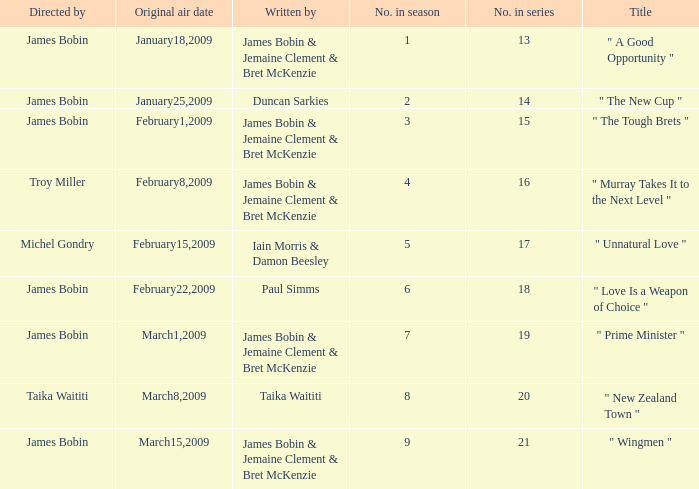 what's the original air date where written by is iain morris & damon beesley February15,2009. 